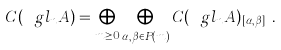Convert formula to latex. <formula><loc_0><loc_0><loc_500><loc_500>C ( \ g l _ { n } A ) = \bigoplus _ { m \geq 0 } \bigoplus _ { \alpha , \beta \in P ( m ) } C ( \ g l _ { n } A ) _ { [ \alpha , \beta ] _ { n } } .</formula> 